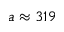<formula> <loc_0><loc_0><loc_500><loc_500>a \approx 3 1 9</formula> 